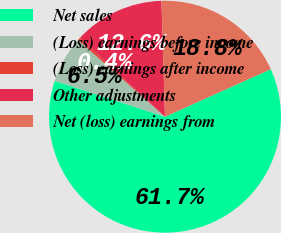<chart> <loc_0><loc_0><loc_500><loc_500><pie_chart><fcel>Net sales<fcel>(Loss) earnings before income<fcel>(Loss) earnings after income<fcel>Other adjustments<fcel>Net (loss) earnings from<nl><fcel>61.72%<fcel>6.5%<fcel>0.37%<fcel>12.64%<fcel>18.77%<nl></chart> 